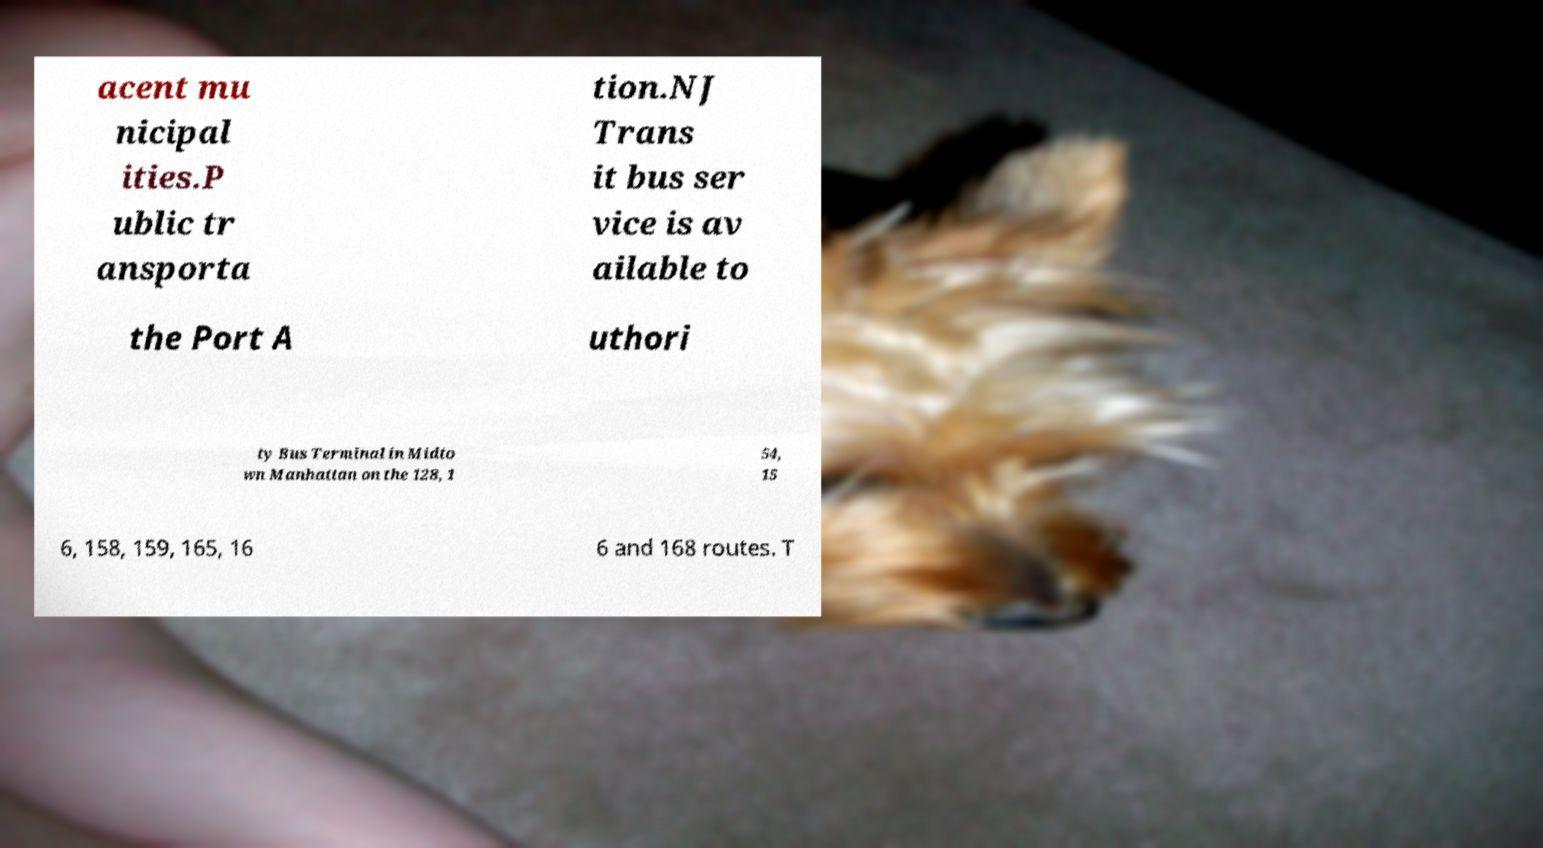Please identify and transcribe the text found in this image. acent mu nicipal ities.P ublic tr ansporta tion.NJ Trans it bus ser vice is av ailable to the Port A uthori ty Bus Terminal in Midto wn Manhattan on the 128, 1 54, 15 6, 158, 159, 165, 16 6 and 168 routes. T 